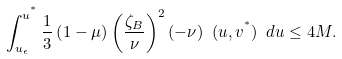Convert formula to latex. <formula><loc_0><loc_0><loc_500><loc_500>\int _ { u _ { \epsilon } } ^ { u ^ { ^ { * } } } \frac { 1 } { 3 } \left ( 1 - \mu \right ) \left ( \frac { \zeta _ { B } } { \nu } \right ) ^ { 2 } ( - \nu ) \ ( u , v ^ { ^ { * } } ) \ d u \leq 4 M .</formula> 